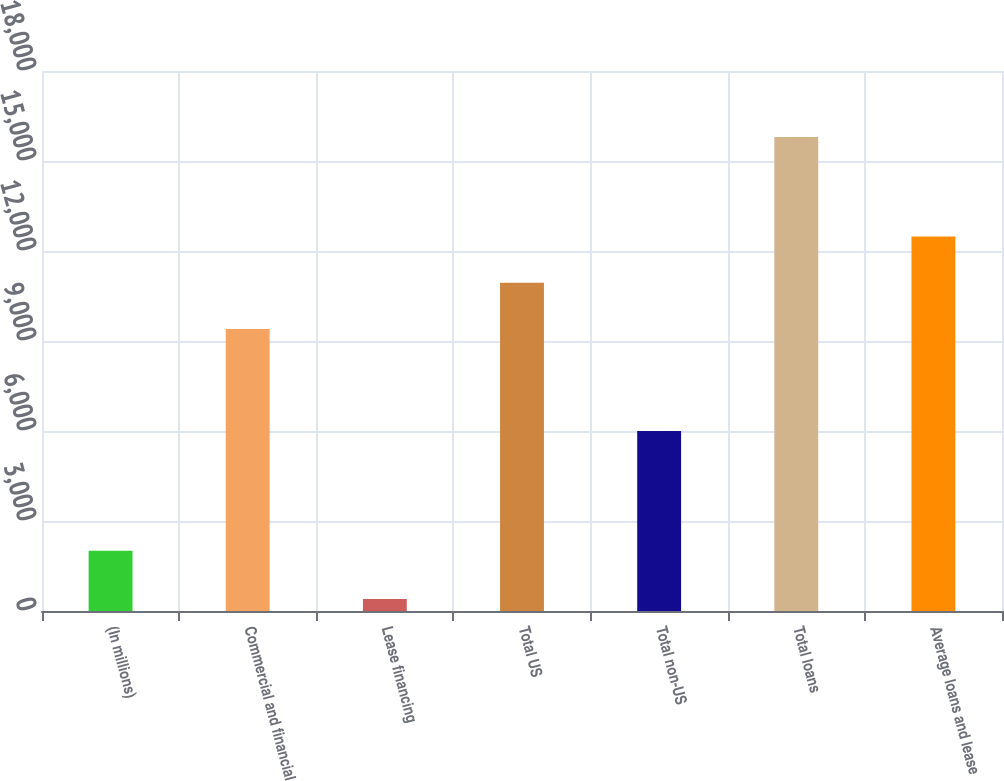Convert chart. <chart><loc_0><loc_0><loc_500><loc_500><bar_chart><fcel>(In millions)<fcel>Commercial and financial<fcel>Lease financing<fcel>Total US<fcel>Total non-US<fcel>Total loans<fcel>Average loans and lease<nl><fcel>2007<fcel>9402<fcel>396<fcel>10942.6<fcel>6004<fcel>15802<fcel>12483.2<nl></chart> 